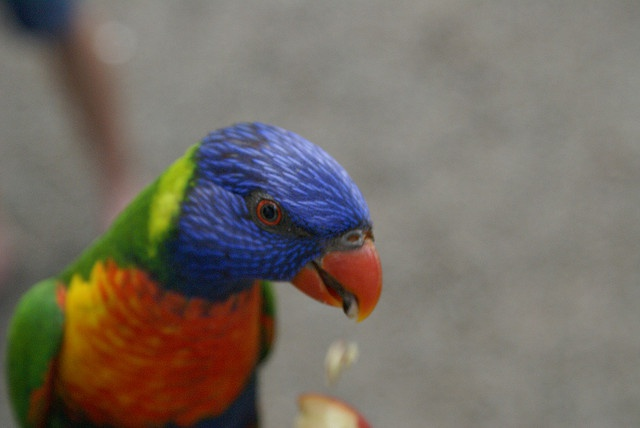Describe the objects in this image and their specific colors. I can see bird in black, maroon, navy, and blue tones and apple in black, tan, and gray tones in this image. 